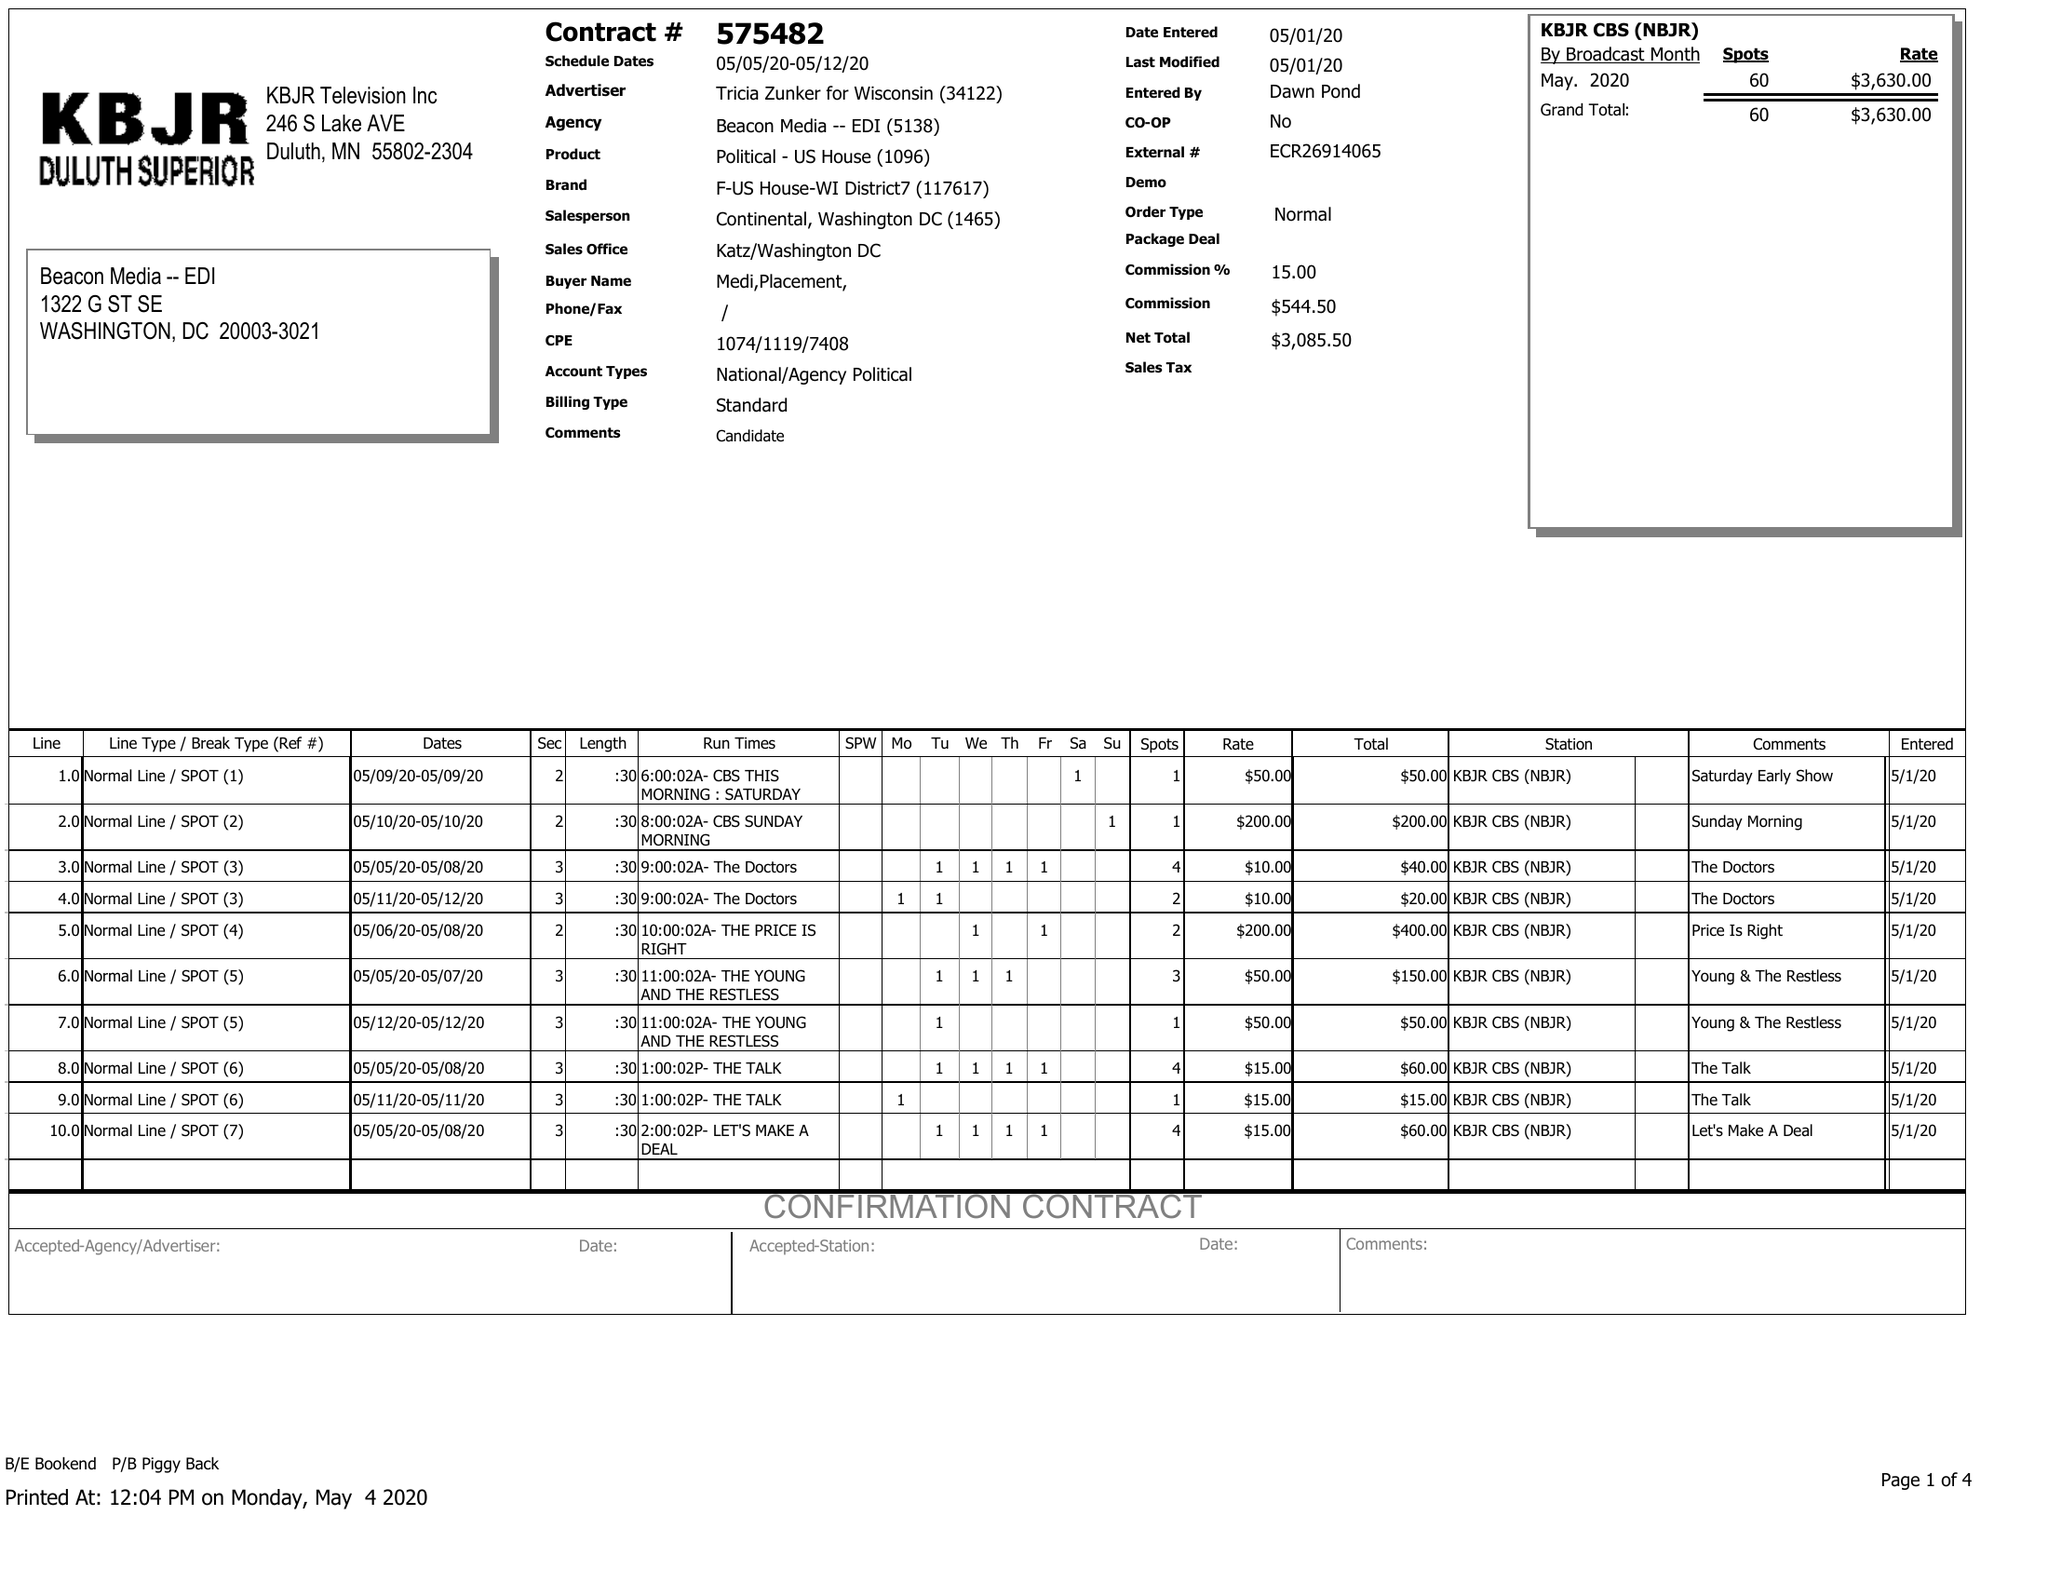What is the value for the contract_num?
Answer the question using a single word or phrase. 575482 